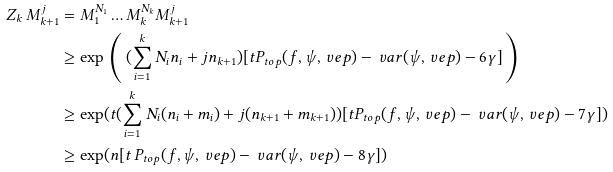<formula> <loc_0><loc_0><loc_500><loc_500>Z _ { k } \, M _ { k + 1 } ^ { j } & = M _ { 1 } ^ { N _ { 1 } } \dots M _ { k } ^ { N _ { k } } M _ { k + 1 } ^ { j } \\ & \geq \exp \, \left ( \, ( \sum _ { i = 1 } ^ { k } N _ { i } n _ { i } + j n _ { k + 1 } ) [ t P _ { t o p } ( f , \psi , \ v e p ) - \ v a r ( \psi , \ v e p ) - 6 \gamma ] \, \right ) \\ & \geq \exp ( t ( \sum _ { i = 1 } ^ { k } N _ { i } ( n _ { i } + m _ { i } ) + j ( n _ { k + 1 } + m _ { k + 1 } ) ) [ t P _ { t o p } ( f , \psi , \ v e p ) - \ v a r ( \psi , \ v e p ) - 7 \gamma ] ) \\ & \geq \exp ( n [ t \, P _ { t o p } ( f , \psi , \ v e p ) - \ v a r ( \psi , \ v e p ) - 8 \gamma ] )</formula> 